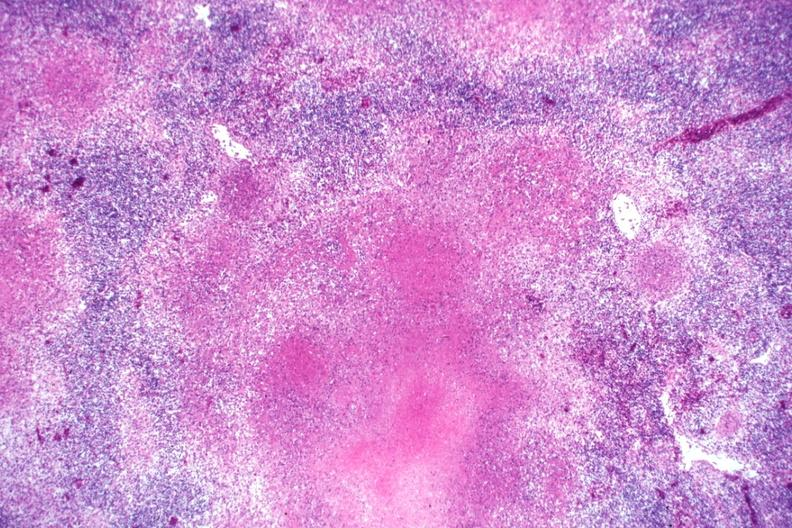what does this image show?
Answer the question using a single word or phrase. Typical necrotizing granulomata becoming confluent an excellent slide 